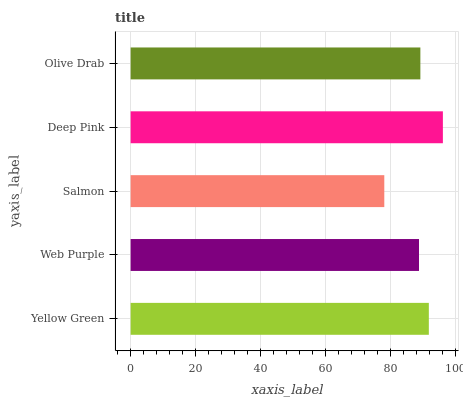Is Salmon the minimum?
Answer yes or no. Yes. Is Deep Pink the maximum?
Answer yes or no. Yes. Is Web Purple the minimum?
Answer yes or no. No. Is Web Purple the maximum?
Answer yes or no. No. Is Yellow Green greater than Web Purple?
Answer yes or no. Yes. Is Web Purple less than Yellow Green?
Answer yes or no. Yes. Is Web Purple greater than Yellow Green?
Answer yes or no. No. Is Yellow Green less than Web Purple?
Answer yes or no. No. Is Olive Drab the high median?
Answer yes or no. Yes. Is Olive Drab the low median?
Answer yes or no. Yes. Is Salmon the high median?
Answer yes or no. No. Is Salmon the low median?
Answer yes or no. No. 